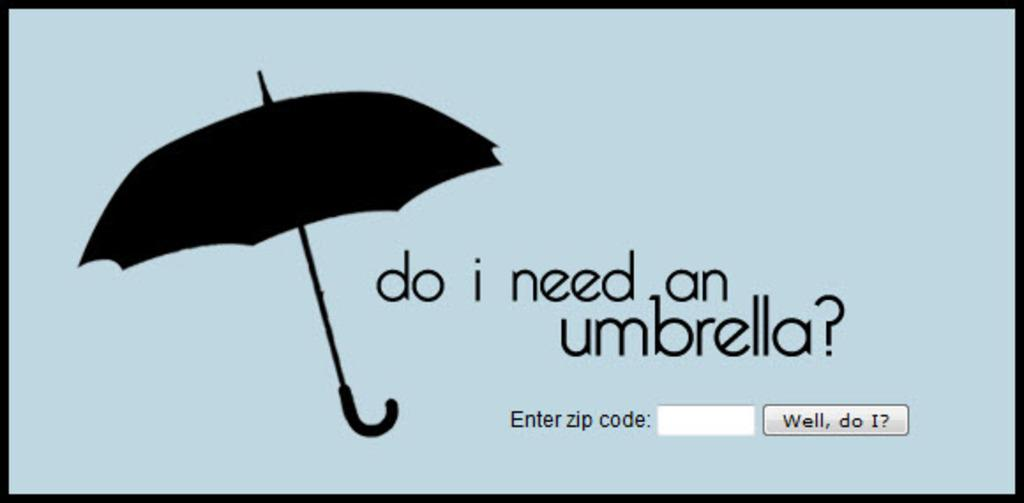What type of image is this? The image is a screenshot of a system. Can you describe the main object visible in the image? There is an object visible in the image, but its specific details cannot be determined from the provided facts. What else can be seen in the image besides the object? There is text present in the image. Who is the owner of the yoke in the image? There is no yoke present in the image, so it is not possible to determine the owner. 